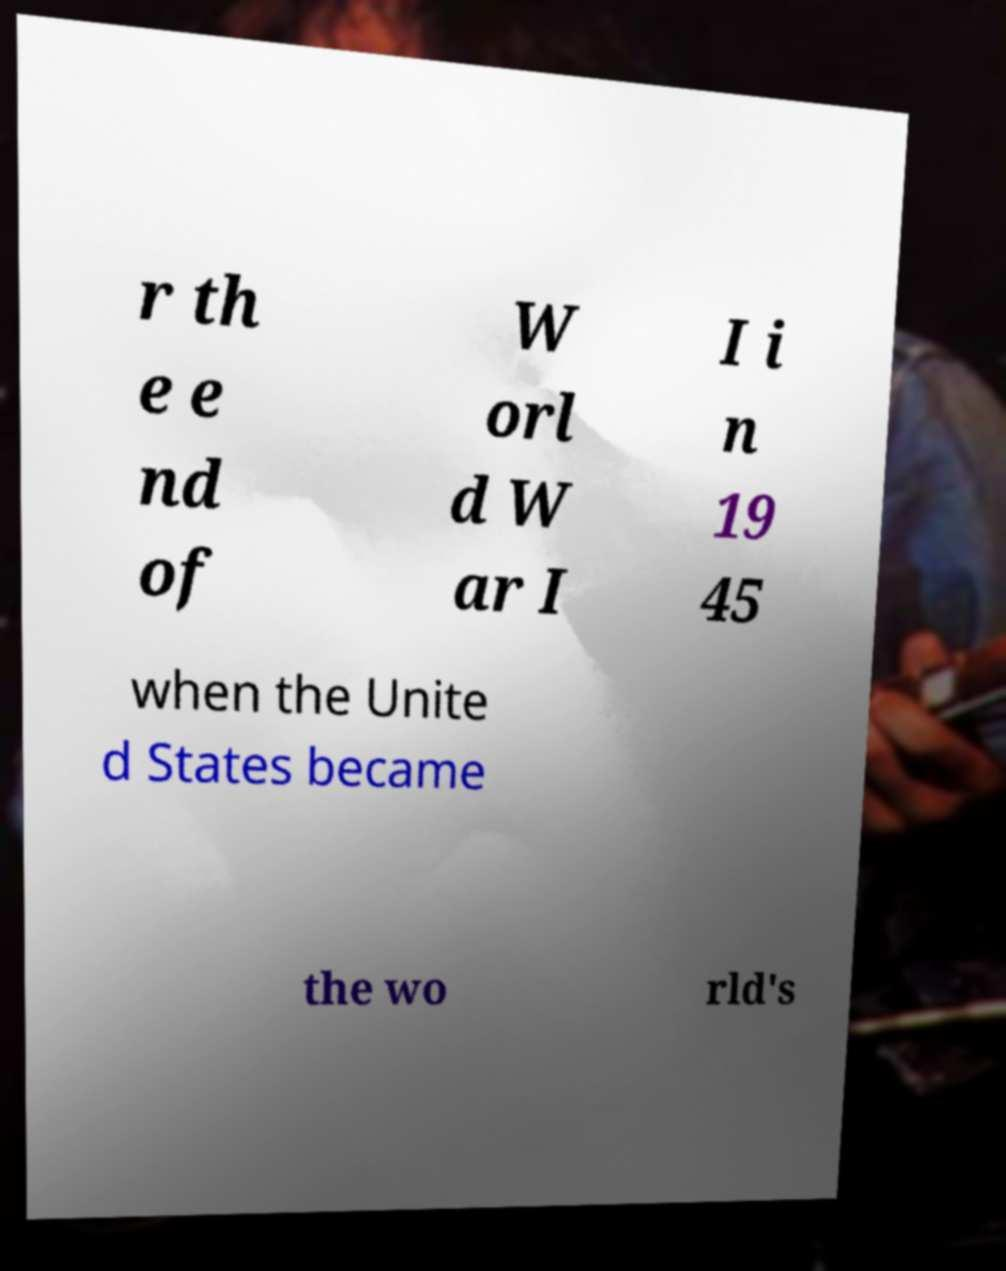Could you extract and type out the text from this image? r th e e nd of W orl d W ar I I i n 19 45 when the Unite d States became the wo rld's 